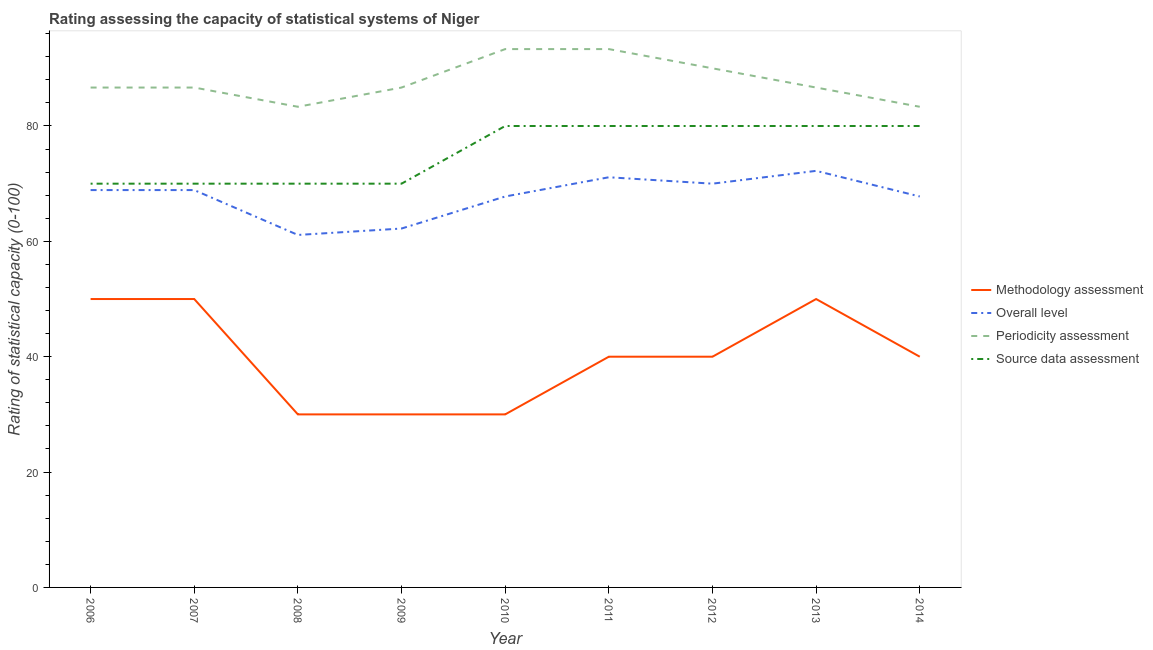Does the line corresponding to source data assessment rating intersect with the line corresponding to periodicity assessment rating?
Offer a terse response. No. Is the number of lines equal to the number of legend labels?
Make the answer very short. Yes. What is the methodology assessment rating in 2011?
Your response must be concise. 40. Across all years, what is the maximum methodology assessment rating?
Provide a succinct answer. 50. Across all years, what is the minimum source data assessment rating?
Your answer should be compact. 70. In which year was the periodicity assessment rating maximum?
Give a very brief answer. 2010. What is the total source data assessment rating in the graph?
Keep it short and to the point. 680. What is the difference between the periodicity assessment rating in 2010 and that in 2012?
Your answer should be very brief. 3.33. What is the difference between the periodicity assessment rating in 2010 and the methodology assessment rating in 2008?
Your response must be concise. 63.33. What is the average source data assessment rating per year?
Give a very brief answer. 75.56. In the year 2008, what is the difference between the periodicity assessment rating and overall level rating?
Provide a succinct answer. 22.22. In how many years, is the methodology assessment rating greater than 44?
Give a very brief answer. 3. What is the ratio of the periodicity assessment rating in 2006 to that in 2013?
Offer a terse response. 1. Is the methodology assessment rating in 2011 less than that in 2012?
Provide a short and direct response. No. Is the difference between the methodology assessment rating in 2007 and 2010 greater than the difference between the source data assessment rating in 2007 and 2010?
Keep it short and to the point. Yes. What is the difference between the highest and the lowest overall level rating?
Offer a terse response. 11.11. In how many years, is the overall level rating greater than the average overall level rating taken over all years?
Give a very brief answer. 7. Is it the case that in every year, the sum of the methodology assessment rating and overall level rating is greater than the periodicity assessment rating?
Offer a very short reply. Yes. Is the methodology assessment rating strictly greater than the overall level rating over the years?
Your answer should be compact. No. How many lines are there?
Ensure brevity in your answer.  4. How many years are there in the graph?
Keep it short and to the point. 9. What is the difference between two consecutive major ticks on the Y-axis?
Provide a short and direct response. 20. Does the graph contain grids?
Your response must be concise. No. Where does the legend appear in the graph?
Make the answer very short. Center right. How many legend labels are there?
Make the answer very short. 4. How are the legend labels stacked?
Your response must be concise. Vertical. What is the title of the graph?
Your answer should be very brief. Rating assessing the capacity of statistical systems of Niger. What is the label or title of the Y-axis?
Your answer should be compact. Rating of statistical capacity (0-100). What is the Rating of statistical capacity (0-100) of Methodology assessment in 2006?
Keep it short and to the point. 50. What is the Rating of statistical capacity (0-100) of Overall level in 2006?
Offer a very short reply. 68.89. What is the Rating of statistical capacity (0-100) of Periodicity assessment in 2006?
Give a very brief answer. 86.67. What is the Rating of statistical capacity (0-100) in Methodology assessment in 2007?
Keep it short and to the point. 50. What is the Rating of statistical capacity (0-100) of Overall level in 2007?
Your answer should be compact. 68.89. What is the Rating of statistical capacity (0-100) in Periodicity assessment in 2007?
Keep it short and to the point. 86.67. What is the Rating of statistical capacity (0-100) in Methodology assessment in 2008?
Provide a succinct answer. 30. What is the Rating of statistical capacity (0-100) in Overall level in 2008?
Make the answer very short. 61.11. What is the Rating of statistical capacity (0-100) of Periodicity assessment in 2008?
Offer a very short reply. 83.33. What is the Rating of statistical capacity (0-100) of Source data assessment in 2008?
Provide a short and direct response. 70. What is the Rating of statistical capacity (0-100) in Overall level in 2009?
Keep it short and to the point. 62.22. What is the Rating of statistical capacity (0-100) of Periodicity assessment in 2009?
Make the answer very short. 86.67. What is the Rating of statistical capacity (0-100) of Methodology assessment in 2010?
Keep it short and to the point. 30. What is the Rating of statistical capacity (0-100) in Overall level in 2010?
Make the answer very short. 67.78. What is the Rating of statistical capacity (0-100) in Periodicity assessment in 2010?
Offer a terse response. 93.33. What is the Rating of statistical capacity (0-100) of Source data assessment in 2010?
Offer a terse response. 80. What is the Rating of statistical capacity (0-100) of Overall level in 2011?
Make the answer very short. 71.11. What is the Rating of statistical capacity (0-100) of Periodicity assessment in 2011?
Your response must be concise. 93.33. What is the Rating of statistical capacity (0-100) in Source data assessment in 2011?
Provide a short and direct response. 80. What is the Rating of statistical capacity (0-100) of Overall level in 2012?
Offer a very short reply. 70. What is the Rating of statistical capacity (0-100) of Methodology assessment in 2013?
Keep it short and to the point. 50. What is the Rating of statistical capacity (0-100) in Overall level in 2013?
Offer a very short reply. 72.22. What is the Rating of statistical capacity (0-100) of Periodicity assessment in 2013?
Your answer should be compact. 86.67. What is the Rating of statistical capacity (0-100) in Methodology assessment in 2014?
Your answer should be compact. 40. What is the Rating of statistical capacity (0-100) in Overall level in 2014?
Your answer should be compact. 67.78. What is the Rating of statistical capacity (0-100) of Periodicity assessment in 2014?
Offer a very short reply. 83.33. Across all years, what is the maximum Rating of statistical capacity (0-100) of Overall level?
Ensure brevity in your answer.  72.22. Across all years, what is the maximum Rating of statistical capacity (0-100) in Periodicity assessment?
Offer a terse response. 93.33. Across all years, what is the minimum Rating of statistical capacity (0-100) in Overall level?
Provide a succinct answer. 61.11. Across all years, what is the minimum Rating of statistical capacity (0-100) in Periodicity assessment?
Your response must be concise. 83.33. What is the total Rating of statistical capacity (0-100) in Methodology assessment in the graph?
Give a very brief answer. 360. What is the total Rating of statistical capacity (0-100) of Overall level in the graph?
Keep it short and to the point. 610. What is the total Rating of statistical capacity (0-100) of Periodicity assessment in the graph?
Your answer should be compact. 790. What is the total Rating of statistical capacity (0-100) in Source data assessment in the graph?
Your answer should be compact. 680. What is the difference between the Rating of statistical capacity (0-100) in Periodicity assessment in 2006 and that in 2007?
Offer a terse response. 0. What is the difference between the Rating of statistical capacity (0-100) of Methodology assessment in 2006 and that in 2008?
Make the answer very short. 20. What is the difference between the Rating of statistical capacity (0-100) of Overall level in 2006 and that in 2008?
Provide a succinct answer. 7.78. What is the difference between the Rating of statistical capacity (0-100) of Methodology assessment in 2006 and that in 2009?
Your answer should be very brief. 20. What is the difference between the Rating of statistical capacity (0-100) of Overall level in 2006 and that in 2009?
Your answer should be very brief. 6.67. What is the difference between the Rating of statistical capacity (0-100) in Periodicity assessment in 2006 and that in 2009?
Give a very brief answer. 0. What is the difference between the Rating of statistical capacity (0-100) in Periodicity assessment in 2006 and that in 2010?
Make the answer very short. -6.67. What is the difference between the Rating of statistical capacity (0-100) in Source data assessment in 2006 and that in 2010?
Give a very brief answer. -10. What is the difference between the Rating of statistical capacity (0-100) of Methodology assessment in 2006 and that in 2011?
Give a very brief answer. 10. What is the difference between the Rating of statistical capacity (0-100) in Overall level in 2006 and that in 2011?
Keep it short and to the point. -2.22. What is the difference between the Rating of statistical capacity (0-100) of Periodicity assessment in 2006 and that in 2011?
Keep it short and to the point. -6.67. What is the difference between the Rating of statistical capacity (0-100) of Overall level in 2006 and that in 2012?
Offer a very short reply. -1.11. What is the difference between the Rating of statistical capacity (0-100) in Methodology assessment in 2006 and that in 2013?
Your answer should be very brief. 0. What is the difference between the Rating of statistical capacity (0-100) in Overall level in 2006 and that in 2013?
Your answer should be very brief. -3.33. What is the difference between the Rating of statistical capacity (0-100) of Periodicity assessment in 2006 and that in 2013?
Keep it short and to the point. 0. What is the difference between the Rating of statistical capacity (0-100) in Source data assessment in 2006 and that in 2013?
Your response must be concise. -10. What is the difference between the Rating of statistical capacity (0-100) in Methodology assessment in 2006 and that in 2014?
Make the answer very short. 10. What is the difference between the Rating of statistical capacity (0-100) of Overall level in 2006 and that in 2014?
Your answer should be very brief. 1.11. What is the difference between the Rating of statistical capacity (0-100) in Periodicity assessment in 2006 and that in 2014?
Provide a short and direct response. 3.33. What is the difference between the Rating of statistical capacity (0-100) of Source data assessment in 2006 and that in 2014?
Offer a terse response. -10. What is the difference between the Rating of statistical capacity (0-100) in Overall level in 2007 and that in 2008?
Make the answer very short. 7.78. What is the difference between the Rating of statistical capacity (0-100) in Periodicity assessment in 2007 and that in 2008?
Offer a terse response. 3.33. What is the difference between the Rating of statistical capacity (0-100) of Periodicity assessment in 2007 and that in 2009?
Give a very brief answer. 0. What is the difference between the Rating of statistical capacity (0-100) of Source data assessment in 2007 and that in 2009?
Your answer should be compact. 0. What is the difference between the Rating of statistical capacity (0-100) in Methodology assessment in 2007 and that in 2010?
Provide a succinct answer. 20. What is the difference between the Rating of statistical capacity (0-100) in Overall level in 2007 and that in 2010?
Offer a terse response. 1.11. What is the difference between the Rating of statistical capacity (0-100) of Periodicity assessment in 2007 and that in 2010?
Provide a short and direct response. -6.67. What is the difference between the Rating of statistical capacity (0-100) in Overall level in 2007 and that in 2011?
Provide a succinct answer. -2.22. What is the difference between the Rating of statistical capacity (0-100) in Periodicity assessment in 2007 and that in 2011?
Make the answer very short. -6.67. What is the difference between the Rating of statistical capacity (0-100) in Source data assessment in 2007 and that in 2011?
Offer a very short reply. -10. What is the difference between the Rating of statistical capacity (0-100) in Overall level in 2007 and that in 2012?
Make the answer very short. -1.11. What is the difference between the Rating of statistical capacity (0-100) in Source data assessment in 2007 and that in 2012?
Your answer should be compact. -10. What is the difference between the Rating of statistical capacity (0-100) in Overall level in 2007 and that in 2013?
Make the answer very short. -3.33. What is the difference between the Rating of statistical capacity (0-100) in Periodicity assessment in 2007 and that in 2013?
Your answer should be compact. 0. What is the difference between the Rating of statistical capacity (0-100) of Source data assessment in 2007 and that in 2013?
Offer a terse response. -10. What is the difference between the Rating of statistical capacity (0-100) of Methodology assessment in 2007 and that in 2014?
Your response must be concise. 10. What is the difference between the Rating of statistical capacity (0-100) in Overall level in 2007 and that in 2014?
Provide a succinct answer. 1.11. What is the difference between the Rating of statistical capacity (0-100) of Periodicity assessment in 2007 and that in 2014?
Make the answer very short. 3.33. What is the difference between the Rating of statistical capacity (0-100) of Source data assessment in 2007 and that in 2014?
Give a very brief answer. -10. What is the difference between the Rating of statistical capacity (0-100) of Methodology assessment in 2008 and that in 2009?
Your answer should be very brief. 0. What is the difference between the Rating of statistical capacity (0-100) of Overall level in 2008 and that in 2009?
Ensure brevity in your answer.  -1.11. What is the difference between the Rating of statistical capacity (0-100) of Source data assessment in 2008 and that in 2009?
Give a very brief answer. 0. What is the difference between the Rating of statistical capacity (0-100) in Overall level in 2008 and that in 2010?
Give a very brief answer. -6.67. What is the difference between the Rating of statistical capacity (0-100) of Source data assessment in 2008 and that in 2010?
Provide a succinct answer. -10. What is the difference between the Rating of statistical capacity (0-100) in Overall level in 2008 and that in 2011?
Your response must be concise. -10. What is the difference between the Rating of statistical capacity (0-100) of Source data assessment in 2008 and that in 2011?
Provide a succinct answer. -10. What is the difference between the Rating of statistical capacity (0-100) in Overall level in 2008 and that in 2012?
Your response must be concise. -8.89. What is the difference between the Rating of statistical capacity (0-100) in Periodicity assessment in 2008 and that in 2012?
Your answer should be very brief. -6.67. What is the difference between the Rating of statistical capacity (0-100) of Source data assessment in 2008 and that in 2012?
Offer a terse response. -10. What is the difference between the Rating of statistical capacity (0-100) in Methodology assessment in 2008 and that in 2013?
Keep it short and to the point. -20. What is the difference between the Rating of statistical capacity (0-100) of Overall level in 2008 and that in 2013?
Your response must be concise. -11.11. What is the difference between the Rating of statistical capacity (0-100) in Periodicity assessment in 2008 and that in 2013?
Give a very brief answer. -3.33. What is the difference between the Rating of statistical capacity (0-100) in Source data assessment in 2008 and that in 2013?
Your response must be concise. -10. What is the difference between the Rating of statistical capacity (0-100) in Overall level in 2008 and that in 2014?
Provide a succinct answer. -6.67. What is the difference between the Rating of statistical capacity (0-100) in Source data assessment in 2008 and that in 2014?
Keep it short and to the point. -10. What is the difference between the Rating of statistical capacity (0-100) of Overall level in 2009 and that in 2010?
Your response must be concise. -5.56. What is the difference between the Rating of statistical capacity (0-100) of Periodicity assessment in 2009 and that in 2010?
Ensure brevity in your answer.  -6.67. What is the difference between the Rating of statistical capacity (0-100) in Methodology assessment in 2009 and that in 2011?
Make the answer very short. -10. What is the difference between the Rating of statistical capacity (0-100) in Overall level in 2009 and that in 2011?
Keep it short and to the point. -8.89. What is the difference between the Rating of statistical capacity (0-100) of Periodicity assessment in 2009 and that in 2011?
Your response must be concise. -6.67. What is the difference between the Rating of statistical capacity (0-100) in Source data assessment in 2009 and that in 2011?
Keep it short and to the point. -10. What is the difference between the Rating of statistical capacity (0-100) in Overall level in 2009 and that in 2012?
Your answer should be very brief. -7.78. What is the difference between the Rating of statistical capacity (0-100) in Source data assessment in 2009 and that in 2012?
Keep it short and to the point. -10. What is the difference between the Rating of statistical capacity (0-100) of Periodicity assessment in 2009 and that in 2013?
Give a very brief answer. 0. What is the difference between the Rating of statistical capacity (0-100) in Source data assessment in 2009 and that in 2013?
Your answer should be compact. -10. What is the difference between the Rating of statistical capacity (0-100) in Methodology assessment in 2009 and that in 2014?
Provide a succinct answer. -10. What is the difference between the Rating of statistical capacity (0-100) in Overall level in 2009 and that in 2014?
Give a very brief answer. -5.56. What is the difference between the Rating of statistical capacity (0-100) of Source data assessment in 2009 and that in 2014?
Your answer should be very brief. -10. What is the difference between the Rating of statistical capacity (0-100) of Periodicity assessment in 2010 and that in 2011?
Your answer should be compact. 0. What is the difference between the Rating of statistical capacity (0-100) of Overall level in 2010 and that in 2012?
Keep it short and to the point. -2.22. What is the difference between the Rating of statistical capacity (0-100) in Periodicity assessment in 2010 and that in 2012?
Provide a short and direct response. 3.33. What is the difference between the Rating of statistical capacity (0-100) in Methodology assessment in 2010 and that in 2013?
Provide a succinct answer. -20. What is the difference between the Rating of statistical capacity (0-100) of Overall level in 2010 and that in 2013?
Provide a short and direct response. -4.44. What is the difference between the Rating of statistical capacity (0-100) of Overall level in 2010 and that in 2014?
Give a very brief answer. 0. What is the difference between the Rating of statistical capacity (0-100) of Source data assessment in 2011 and that in 2012?
Keep it short and to the point. 0. What is the difference between the Rating of statistical capacity (0-100) in Methodology assessment in 2011 and that in 2013?
Offer a terse response. -10. What is the difference between the Rating of statistical capacity (0-100) in Overall level in 2011 and that in 2013?
Your response must be concise. -1.11. What is the difference between the Rating of statistical capacity (0-100) in Periodicity assessment in 2011 and that in 2014?
Your answer should be compact. 10. What is the difference between the Rating of statistical capacity (0-100) in Source data assessment in 2011 and that in 2014?
Give a very brief answer. 0. What is the difference between the Rating of statistical capacity (0-100) of Methodology assessment in 2012 and that in 2013?
Ensure brevity in your answer.  -10. What is the difference between the Rating of statistical capacity (0-100) of Overall level in 2012 and that in 2013?
Provide a succinct answer. -2.22. What is the difference between the Rating of statistical capacity (0-100) in Methodology assessment in 2012 and that in 2014?
Your answer should be very brief. 0. What is the difference between the Rating of statistical capacity (0-100) of Overall level in 2012 and that in 2014?
Give a very brief answer. 2.22. What is the difference between the Rating of statistical capacity (0-100) of Periodicity assessment in 2012 and that in 2014?
Offer a very short reply. 6.67. What is the difference between the Rating of statistical capacity (0-100) of Methodology assessment in 2013 and that in 2014?
Give a very brief answer. 10. What is the difference between the Rating of statistical capacity (0-100) of Overall level in 2013 and that in 2014?
Keep it short and to the point. 4.44. What is the difference between the Rating of statistical capacity (0-100) of Periodicity assessment in 2013 and that in 2014?
Provide a short and direct response. 3.33. What is the difference between the Rating of statistical capacity (0-100) of Source data assessment in 2013 and that in 2014?
Your answer should be compact. 0. What is the difference between the Rating of statistical capacity (0-100) in Methodology assessment in 2006 and the Rating of statistical capacity (0-100) in Overall level in 2007?
Give a very brief answer. -18.89. What is the difference between the Rating of statistical capacity (0-100) in Methodology assessment in 2006 and the Rating of statistical capacity (0-100) in Periodicity assessment in 2007?
Your answer should be very brief. -36.67. What is the difference between the Rating of statistical capacity (0-100) in Overall level in 2006 and the Rating of statistical capacity (0-100) in Periodicity assessment in 2007?
Give a very brief answer. -17.78. What is the difference between the Rating of statistical capacity (0-100) in Overall level in 2006 and the Rating of statistical capacity (0-100) in Source data assessment in 2007?
Make the answer very short. -1.11. What is the difference between the Rating of statistical capacity (0-100) in Periodicity assessment in 2006 and the Rating of statistical capacity (0-100) in Source data assessment in 2007?
Provide a succinct answer. 16.67. What is the difference between the Rating of statistical capacity (0-100) in Methodology assessment in 2006 and the Rating of statistical capacity (0-100) in Overall level in 2008?
Offer a very short reply. -11.11. What is the difference between the Rating of statistical capacity (0-100) of Methodology assessment in 2006 and the Rating of statistical capacity (0-100) of Periodicity assessment in 2008?
Offer a very short reply. -33.33. What is the difference between the Rating of statistical capacity (0-100) of Methodology assessment in 2006 and the Rating of statistical capacity (0-100) of Source data assessment in 2008?
Provide a succinct answer. -20. What is the difference between the Rating of statistical capacity (0-100) of Overall level in 2006 and the Rating of statistical capacity (0-100) of Periodicity assessment in 2008?
Offer a terse response. -14.44. What is the difference between the Rating of statistical capacity (0-100) in Overall level in 2006 and the Rating of statistical capacity (0-100) in Source data assessment in 2008?
Offer a terse response. -1.11. What is the difference between the Rating of statistical capacity (0-100) of Periodicity assessment in 2006 and the Rating of statistical capacity (0-100) of Source data assessment in 2008?
Offer a terse response. 16.67. What is the difference between the Rating of statistical capacity (0-100) of Methodology assessment in 2006 and the Rating of statistical capacity (0-100) of Overall level in 2009?
Your answer should be very brief. -12.22. What is the difference between the Rating of statistical capacity (0-100) of Methodology assessment in 2006 and the Rating of statistical capacity (0-100) of Periodicity assessment in 2009?
Give a very brief answer. -36.67. What is the difference between the Rating of statistical capacity (0-100) of Overall level in 2006 and the Rating of statistical capacity (0-100) of Periodicity assessment in 2009?
Ensure brevity in your answer.  -17.78. What is the difference between the Rating of statistical capacity (0-100) in Overall level in 2006 and the Rating of statistical capacity (0-100) in Source data assessment in 2009?
Keep it short and to the point. -1.11. What is the difference between the Rating of statistical capacity (0-100) in Periodicity assessment in 2006 and the Rating of statistical capacity (0-100) in Source data assessment in 2009?
Keep it short and to the point. 16.67. What is the difference between the Rating of statistical capacity (0-100) of Methodology assessment in 2006 and the Rating of statistical capacity (0-100) of Overall level in 2010?
Provide a succinct answer. -17.78. What is the difference between the Rating of statistical capacity (0-100) of Methodology assessment in 2006 and the Rating of statistical capacity (0-100) of Periodicity assessment in 2010?
Offer a very short reply. -43.33. What is the difference between the Rating of statistical capacity (0-100) in Methodology assessment in 2006 and the Rating of statistical capacity (0-100) in Source data assessment in 2010?
Make the answer very short. -30. What is the difference between the Rating of statistical capacity (0-100) in Overall level in 2006 and the Rating of statistical capacity (0-100) in Periodicity assessment in 2010?
Your answer should be compact. -24.44. What is the difference between the Rating of statistical capacity (0-100) of Overall level in 2006 and the Rating of statistical capacity (0-100) of Source data assessment in 2010?
Your answer should be compact. -11.11. What is the difference between the Rating of statistical capacity (0-100) of Methodology assessment in 2006 and the Rating of statistical capacity (0-100) of Overall level in 2011?
Provide a short and direct response. -21.11. What is the difference between the Rating of statistical capacity (0-100) of Methodology assessment in 2006 and the Rating of statistical capacity (0-100) of Periodicity assessment in 2011?
Keep it short and to the point. -43.33. What is the difference between the Rating of statistical capacity (0-100) in Overall level in 2006 and the Rating of statistical capacity (0-100) in Periodicity assessment in 2011?
Keep it short and to the point. -24.44. What is the difference between the Rating of statistical capacity (0-100) in Overall level in 2006 and the Rating of statistical capacity (0-100) in Source data assessment in 2011?
Your response must be concise. -11.11. What is the difference between the Rating of statistical capacity (0-100) in Periodicity assessment in 2006 and the Rating of statistical capacity (0-100) in Source data assessment in 2011?
Your response must be concise. 6.67. What is the difference between the Rating of statistical capacity (0-100) in Methodology assessment in 2006 and the Rating of statistical capacity (0-100) in Overall level in 2012?
Your answer should be compact. -20. What is the difference between the Rating of statistical capacity (0-100) in Methodology assessment in 2006 and the Rating of statistical capacity (0-100) in Source data assessment in 2012?
Make the answer very short. -30. What is the difference between the Rating of statistical capacity (0-100) in Overall level in 2006 and the Rating of statistical capacity (0-100) in Periodicity assessment in 2012?
Keep it short and to the point. -21.11. What is the difference between the Rating of statistical capacity (0-100) of Overall level in 2006 and the Rating of statistical capacity (0-100) of Source data assessment in 2012?
Offer a very short reply. -11.11. What is the difference between the Rating of statistical capacity (0-100) of Periodicity assessment in 2006 and the Rating of statistical capacity (0-100) of Source data assessment in 2012?
Provide a succinct answer. 6.67. What is the difference between the Rating of statistical capacity (0-100) of Methodology assessment in 2006 and the Rating of statistical capacity (0-100) of Overall level in 2013?
Your answer should be compact. -22.22. What is the difference between the Rating of statistical capacity (0-100) of Methodology assessment in 2006 and the Rating of statistical capacity (0-100) of Periodicity assessment in 2013?
Keep it short and to the point. -36.67. What is the difference between the Rating of statistical capacity (0-100) of Overall level in 2006 and the Rating of statistical capacity (0-100) of Periodicity assessment in 2013?
Your response must be concise. -17.78. What is the difference between the Rating of statistical capacity (0-100) of Overall level in 2006 and the Rating of statistical capacity (0-100) of Source data assessment in 2013?
Provide a short and direct response. -11.11. What is the difference between the Rating of statistical capacity (0-100) of Periodicity assessment in 2006 and the Rating of statistical capacity (0-100) of Source data assessment in 2013?
Ensure brevity in your answer.  6.67. What is the difference between the Rating of statistical capacity (0-100) of Methodology assessment in 2006 and the Rating of statistical capacity (0-100) of Overall level in 2014?
Your answer should be compact. -17.78. What is the difference between the Rating of statistical capacity (0-100) of Methodology assessment in 2006 and the Rating of statistical capacity (0-100) of Periodicity assessment in 2014?
Provide a succinct answer. -33.33. What is the difference between the Rating of statistical capacity (0-100) of Overall level in 2006 and the Rating of statistical capacity (0-100) of Periodicity assessment in 2014?
Your response must be concise. -14.44. What is the difference between the Rating of statistical capacity (0-100) of Overall level in 2006 and the Rating of statistical capacity (0-100) of Source data assessment in 2014?
Your answer should be very brief. -11.11. What is the difference between the Rating of statistical capacity (0-100) in Methodology assessment in 2007 and the Rating of statistical capacity (0-100) in Overall level in 2008?
Offer a very short reply. -11.11. What is the difference between the Rating of statistical capacity (0-100) in Methodology assessment in 2007 and the Rating of statistical capacity (0-100) in Periodicity assessment in 2008?
Provide a succinct answer. -33.33. What is the difference between the Rating of statistical capacity (0-100) of Overall level in 2007 and the Rating of statistical capacity (0-100) of Periodicity assessment in 2008?
Offer a very short reply. -14.44. What is the difference between the Rating of statistical capacity (0-100) of Overall level in 2007 and the Rating of statistical capacity (0-100) of Source data assessment in 2008?
Offer a very short reply. -1.11. What is the difference between the Rating of statistical capacity (0-100) in Periodicity assessment in 2007 and the Rating of statistical capacity (0-100) in Source data assessment in 2008?
Make the answer very short. 16.67. What is the difference between the Rating of statistical capacity (0-100) in Methodology assessment in 2007 and the Rating of statistical capacity (0-100) in Overall level in 2009?
Offer a terse response. -12.22. What is the difference between the Rating of statistical capacity (0-100) in Methodology assessment in 2007 and the Rating of statistical capacity (0-100) in Periodicity assessment in 2009?
Make the answer very short. -36.67. What is the difference between the Rating of statistical capacity (0-100) in Overall level in 2007 and the Rating of statistical capacity (0-100) in Periodicity assessment in 2009?
Provide a short and direct response. -17.78. What is the difference between the Rating of statistical capacity (0-100) of Overall level in 2007 and the Rating of statistical capacity (0-100) of Source data assessment in 2009?
Offer a terse response. -1.11. What is the difference between the Rating of statistical capacity (0-100) of Periodicity assessment in 2007 and the Rating of statistical capacity (0-100) of Source data assessment in 2009?
Your answer should be compact. 16.67. What is the difference between the Rating of statistical capacity (0-100) of Methodology assessment in 2007 and the Rating of statistical capacity (0-100) of Overall level in 2010?
Your response must be concise. -17.78. What is the difference between the Rating of statistical capacity (0-100) in Methodology assessment in 2007 and the Rating of statistical capacity (0-100) in Periodicity assessment in 2010?
Provide a succinct answer. -43.33. What is the difference between the Rating of statistical capacity (0-100) in Overall level in 2007 and the Rating of statistical capacity (0-100) in Periodicity assessment in 2010?
Keep it short and to the point. -24.44. What is the difference between the Rating of statistical capacity (0-100) of Overall level in 2007 and the Rating of statistical capacity (0-100) of Source data assessment in 2010?
Your answer should be compact. -11.11. What is the difference between the Rating of statistical capacity (0-100) in Periodicity assessment in 2007 and the Rating of statistical capacity (0-100) in Source data assessment in 2010?
Ensure brevity in your answer.  6.67. What is the difference between the Rating of statistical capacity (0-100) in Methodology assessment in 2007 and the Rating of statistical capacity (0-100) in Overall level in 2011?
Provide a short and direct response. -21.11. What is the difference between the Rating of statistical capacity (0-100) in Methodology assessment in 2007 and the Rating of statistical capacity (0-100) in Periodicity assessment in 2011?
Your answer should be very brief. -43.33. What is the difference between the Rating of statistical capacity (0-100) of Overall level in 2007 and the Rating of statistical capacity (0-100) of Periodicity assessment in 2011?
Your answer should be compact. -24.44. What is the difference between the Rating of statistical capacity (0-100) of Overall level in 2007 and the Rating of statistical capacity (0-100) of Source data assessment in 2011?
Offer a very short reply. -11.11. What is the difference between the Rating of statistical capacity (0-100) in Methodology assessment in 2007 and the Rating of statistical capacity (0-100) in Periodicity assessment in 2012?
Your answer should be very brief. -40. What is the difference between the Rating of statistical capacity (0-100) of Methodology assessment in 2007 and the Rating of statistical capacity (0-100) of Source data assessment in 2012?
Ensure brevity in your answer.  -30. What is the difference between the Rating of statistical capacity (0-100) in Overall level in 2007 and the Rating of statistical capacity (0-100) in Periodicity assessment in 2012?
Your response must be concise. -21.11. What is the difference between the Rating of statistical capacity (0-100) of Overall level in 2007 and the Rating of statistical capacity (0-100) of Source data assessment in 2012?
Your response must be concise. -11.11. What is the difference between the Rating of statistical capacity (0-100) in Periodicity assessment in 2007 and the Rating of statistical capacity (0-100) in Source data assessment in 2012?
Offer a terse response. 6.67. What is the difference between the Rating of statistical capacity (0-100) in Methodology assessment in 2007 and the Rating of statistical capacity (0-100) in Overall level in 2013?
Give a very brief answer. -22.22. What is the difference between the Rating of statistical capacity (0-100) in Methodology assessment in 2007 and the Rating of statistical capacity (0-100) in Periodicity assessment in 2013?
Offer a terse response. -36.67. What is the difference between the Rating of statistical capacity (0-100) of Overall level in 2007 and the Rating of statistical capacity (0-100) of Periodicity assessment in 2013?
Your response must be concise. -17.78. What is the difference between the Rating of statistical capacity (0-100) of Overall level in 2007 and the Rating of statistical capacity (0-100) of Source data assessment in 2013?
Give a very brief answer. -11.11. What is the difference between the Rating of statistical capacity (0-100) in Methodology assessment in 2007 and the Rating of statistical capacity (0-100) in Overall level in 2014?
Your answer should be very brief. -17.78. What is the difference between the Rating of statistical capacity (0-100) of Methodology assessment in 2007 and the Rating of statistical capacity (0-100) of Periodicity assessment in 2014?
Offer a terse response. -33.33. What is the difference between the Rating of statistical capacity (0-100) in Methodology assessment in 2007 and the Rating of statistical capacity (0-100) in Source data assessment in 2014?
Provide a succinct answer. -30. What is the difference between the Rating of statistical capacity (0-100) in Overall level in 2007 and the Rating of statistical capacity (0-100) in Periodicity assessment in 2014?
Keep it short and to the point. -14.44. What is the difference between the Rating of statistical capacity (0-100) in Overall level in 2007 and the Rating of statistical capacity (0-100) in Source data assessment in 2014?
Your answer should be compact. -11.11. What is the difference between the Rating of statistical capacity (0-100) of Periodicity assessment in 2007 and the Rating of statistical capacity (0-100) of Source data assessment in 2014?
Offer a terse response. 6.67. What is the difference between the Rating of statistical capacity (0-100) in Methodology assessment in 2008 and the Rating of statistical capacity (0-100) in Overall level in 2009?
Make the answer very short. -32.22. What is the difference between the Rating of statistical capacity (0-100) of Methodology assessment in 2008 and the Rating of statistical capacity (0-100) of Periodicity assessment in 2009?
Your response must be concise. -56.67. What is the difference between the Rating of statistical capacity (0-100) of Methodology assessment in 2008 and the Rating of statistical capacity (0-100) of Source data assessment in 2009?
Offer a very short reply. -40. What is the difference between the Rating of statistical capacity (0-100) in Overall level in 2008 and the Rating of statistical capacity (0-100) in Periodicity assessment in 2009?
Offer a terse response. -25.56. What is the difference between the Rating of statistical capacity (0-100) of Overall level in 2008 and the Rating of statistical capacity (0-100) of Source data assessment in 2009?
Give a very brief answer. -8.89. What is the difference between the Rating of statistical capacity (0-100) in Periodicity assessment in 2008 and the Rating of statistical capacity (0-100) in Source data assessment in 2009?
Make the answer very short. 13.33. What is the difference between the Rating of statistical capacity (0-100) in Methodology assessment in 2008 and the Rating of statistical capacity (0-100) in Overall level in 2010?
Provide a succinct answer. -37.78. What is the difference between the Rating of statistical capacity (0-100) in Methodology assessment in 2008 and the Rating of statistical capacity (0-100) in Periodicity assessment in 2010?
Keep it short and to the point. -63.33. What is the difference between the Rating of statistical capacity (0-100) in Overall level in 2008 and the Rating of statistical capacity (0-100) in Periodicity assessment in 2010?
Your answer should be very brief. -32.22. What is the difference between the Rating of statistical capacity (0-100) in Overall level in 2008 and the Rating of statistical capacity (0-100) in Source data assessment in 2010?
Provide a short and direct response. -18.89. What is the difference between the Rating of statistical capacity (0-100) of Periodicity assessment in 2008 and the Rating of statistical capacity (0-100) of Source data assessment in 2010?
Provide a short and direct response. 3.33. What is the difference between the Rating of statistical capacity (0-100) of Methodology assessment in 2008 and the Rating of statistical capacity (0-100) of Overall level in 2011?
Your answer should be very brief. -41.11. What is the difference between the Rating of statistical capacity (0-100) in Methodology assessment in 2008 and the Rating of statistical capacity (0-100) in Periodicity assessment in 2011?
Make the answer very short. -63.33. What is the difference between the Rating of statistical capacity (0-100) of Overall level in 2008 and the Rating of statistical capacity (0-100) of Periodicity assessment in 2011?
Your response must be concise. -32.22. What is the difference between the Rating of statistical capacity (0-100) in Overall level in 2008 and the Rating of statistical capacity (0-100) in Source data assessment in 2011?
Offer a very short reply. -18.89. What is the difference between the Rating of statistical capacity (0-100) in Methodology assessment in 2008 and the Rating of statistical capacity (0-100) in Overall level in 2012?
Ensure brevity in your answer.  -40. What is the difference between the Rating of statistical capacity (0-100) in Methodology assessment in 2008 and the Rating of statistical capacity (0-100) in Periodicity assessment in 2012?
Keep it short and to the point. -60. What is the difference between the Rating of statistical capacity (0-100) in Methodology assessment in 2008 and the Rating of statistical capacity (0-100) in Source data assessment in 2012?
Provide a short and direct response. -50. What is the difference between the Rating of statistical capacity (0-100) in Overall level in 2008 and the Rating of statistical capacity (0-100) in Periodicity assessment in 2012?
Your answer should be very brief. -28.89. What is the difference between the Rating of statistical capacity (0-100) of Overall level in 2008 and the Rating of statistical capacity (0-100) of Source data assessment in 2012?
Your answer should be compact. -18.89. What is the difference between the Rating of statistical capacity (0-100) in Methodology assessment in 2008 and the Rating of statistical capacity (0-100) in Overall level in 2013?
Your response must be concise. -42.22. What is the difference between the Rating of statistical capacity (0-100) of Methodology assessment in 2008 and the Rating of statistical capacity (0-100) of Periodicity assessment in 2013?
Your answer should be compact. -56.67. What is the difference between the Rating of statistical capacity (0-100) of Overall level in 2008 and the Rating of statistical capacity (0-100) of Periodicity assessment in 2013?
Ensure brevity in your answer.  -25.56. What is the difference between the Rating of statistical capacity (0-100) of Overall level in 2008 and the Rating of statistical capacity (0-100) of Source data assessment in 2013?
Offer a terse response. -18.89. What is the difference between the Rating of statistical capacity (0-100) in Methodology assessment in 2008 and the Rating of statistical capacity (0-100) in Overall level in 2014?
Offer a very short reply. -37.78. What is the difference between the Rating of statistical capacity (0-100) of Methodology assessment in 2008 and the Rating of statistical capacity (0-100) of Periodicity assessment in 2014?
Offer a terse response. -53.33. What is the difference between the Rating of statistical capacity (0-100) of Methodology assessment in 2008 and the Rating of statistical capacity (0-100) of Source data assessment in 2014?
Your answer should be very brief. -50. What is the difference between the Rating of statistical capacity (0-100) of Overall level in 2008 and the Rating of statistical capacity (0-100) of Periodicity assessment in 2014?
Your answer should be very brief. -22.22. What is the difference between the Rating of statistical capacity (0-100) of Overall level in 2008 and the Rating of statistical capacity (0-100) of Source data assessment in 2014?
Your answer should be compact. -18.89. What is the difference between the Rating of statistical capacity (0-100) in Periodicity assessment in 2008 and the Rating of statistical capacity (0-100) in Source data assessment in 2014?
Your answer should be compact. 3.33. What is the difference between the Rating of statistical capacity (0-100) in Methodology assessment in 2009 and the Rating of statistical capacity (0-100) in Overall level in 2010?
Offer a terse response. -37.78. What is the difference between the Rating of statistical capacity (0-100) in Methodology assessment in 2009 and the Rating of statistical capacity (0-100) in Periodicity assessment in 2010?
Provide a succinct answer. -63.33. What is the difference between the Rating of statistical capacity (0-100) in Overall level in 2009 and the Rating of statistical capacity (0-100) in Periodicity assessment in 2010?
Provide a short and direct response. -31.11. What is the difference between the Rating of statistical capacity (0-100) in Overall level in 2009 and the Rating of statistical capacity (0-100) in Source data assessment in 2010?
Your response must be concise. -17.78. What is the difference between the Rating of statistical capacity (0-100) in Periodicity assessment in 2009 and the Rating of statistical capacity (0-100) in Source data assessment in 2010?
Your answer should be compact. 6.67. What is the difference between the Rating of statistical capacity (0-100) in Methodology assessment in 2009 and the Rating of statistical capacity (0-100) in Overall level in 2011?
Ensure brevity in your answer.  -41.11. What is the difference between the Rating of statistical capacity (0-100) of Methodology assessment in 2009 and the Rating of statistical capacity (0-100) of Periodicity assessment in 2011?
Offer a very short reply. -63.33. What is the difference between the Rating of statistical capacity (0-100) of Methodology assessment in 2009 and the Rating of statistical capacity (0-100) of Source data assessment in 2011?
Ensure brevity in your answer.  -50. What is the difference between the Rating of statistical capacity (0-100) in Overall level in 2009 and the Rating of statistical capacity (0-100) in Periodicity assessment in 2011?
Provide a short and direct response. -31.11. What is the difference between the Rating of statistical capacity (0-100) of Overall level in 2009 and the Rating of statistical capacity (0-100) of Source data assessment in 2011?
Ensure brevity in your answer.  -17.78. What is the difference between the Rating of statistical capacity (0-100) in Methodology assessment in 2009 and the Rating of statistical capacity (0-100) in Overall level in 2012?
Provide a short and direct response. -40. What is the difference between the Rating of statistical capacity (0-100) of Methodology assessment in 2009 and the Rating of statistical capacity (0-100) of Periodicity assessment in 2012?
Your answer should be compact. -60. What is the difference between the Rating of statistical capacity (0-100) in Overall level in 2009 and the Rating of statistical capacity (0-100) in Periodicity assessment in 2012?
Provide a succinct answer. -27.78. What is the difference between the Rating of statistical capacity (0-100) in Overall level in 2009 and the Rating of statistical capacity (0-100) in Source data assessment in 2012?
Provide a succinct answer. -17.78. What is the difference between the Rating of statistical capacity (0-100) of Methodology assessment in 2009 and the Rating of statistical capacity (0-100) of Overall level in 2013?
Make the answer very short. -42.22. What is the difference between the Rating of statistical capacity (0-100) in Methodology assessment in 2009 and the Rating of statistical capacity (0-100) in Periodicity assessment in 2013?
Offer a very short reply. -56.67. What is the difference between the Rating of statistical capacity (0-100) in Overall level in 2009 and the Rating of statistical capacity (0-100) in Periodicity assessment in 2013?
Give a very brief answer. -24.44. What is the difference between the Rating of statistical capacity (0-100) in Overall level in 2009 and the Rating of statistical capacity (0-100) in Source data assessment in 2013?
Your answer should be compact. -17.78. What is the difference between the Rating of statistical capacity (0-100) in Periodicity assessment in 2009 and the Rating of statistical capacity (0-100) in Source data assessment in 2013?
Provide a short and direct response. 6.67. What is the difference between the Rating of statistical capacity (0-100) in Methodology assessment in 2009 and the Rating of statistical capacity (0-100) in Overall level in 2014?
Provide a short and direct response. -37.78. What is the difference between the Rating of statistical capacity (0-100) of Methodology assessment in 2009 and the Rating of statistical capacity (0-100) of Periodicity assessment in 2014?
Offer a terse response. -53.33. What is the difference between the Rating of statistical capacity (0-100) in Methodology assessment in 2009 and the Rating of statistical capacity (0-100) in Source data assessment in 2014?
Provide a short and direct response. -50. What is the difference between the Rating of statistical capacity (0-100) of Overall level in 2009 and the Rating of statistical capacity (0-100) of Periodicity assessment in 2014?
Provide a succinct answer. -21.11. What is the difference between the Rating of statistical capacity (0-100) of Overall level in 2009 and the Rating of statistical capacity (0-100) of Source data assessment in 2014?
Your answer should be very brief. -17.78. What is the difference between the Rating of statistical capacity (0-100) of Periodicity assessment in 2009 and the Rating of statistical capacity (0-100) of Source data assessment in 2014?
Your response must be concise. 6.67. What is the difference between the Rating of statistical capacity (0-100) of Methodology assessment in 2010 and the Rating of statistical capacity (0-100) of Overall level in 2011?
Offer a very short reply. -41.11. What is the difference between the Rating of statistical capacity (0-100) in Methodology assessment in 2010 and the Rating of statistical capacity (0-100) in Periodicity assessment in 2011?
Your response must be concise. -63.33. What is the difference between the Rating of statistical capacity (0-100) of Methodology assessment in 2010 and the Rating of statistical capacity (0-100) of Source data assessment in 2011?
Ensure brevity in your answer.  -50. What is the difference between the Rating of statistical capacity (0-100) of Overall level in 2010 and the Rating of statistical capacity (0-100) of Periodicity assessment in 2011?
Your answer should be compact. -25.56. What is the difference between the Rating of statistical capacity (0-100) of Overall level in 2010 and the Rating of statistical capacity (0-100) of Source data assessment in 2011?
Provide a short and direct response. -12.22. What is the difference between the Rating of statistical capacity (0-100) of Periodicity assessment in 2010 and the Rating of statistical capacity (0-100) of Source data assessment in 2011?
Give a very brief answer. 13.33. What is the difference between the Rating of statistical capacity (0-100) in Methodology assessment in 2010 and the Rating of statistical capacity (0-100) in Overall level in 2012?
Offer a very short reply. -40. What is the difference between the Rating of statistical capacity (0-100) of Methodology assessment in 2010 and the Rating of statistical capacity (0-100) of Periodicity assessment in 2012?
Your answer should be compact. -60. What is the difference between the Rating of statistical capacity (0-100) in Methodology assessment in 2010 and the Rating of statistical capacity (0-100) in Source data assessment in 2012?
Provide a succinct answer. -50. What is the difference between the Rating of statistical capacity (0-100) of Overall level in 2010 and the Rating of statistical capacity (0-100) of Periodicity assessment in 2012?
Offer a very short reply. -22.22. What is the difference between the Rating of statistical capacity (0-100) in Overall level in 2010 and the Rating of statistical capacity (0-100) in Source data assessment in 2012?
Your answer should be very brief. -12.22. What is the difference between the Rating of statistical capacity (0-100) in Periodicity assessment in 2010 and the Rating of statistical capacity (0-100) in Source data assessment in 2012?
Your answer should be compact. 13.33. What is the difference between the Rating of statistical capacity (0-100) of Methodology assessment in 2010 and the Rating of statistical capacity (0-100) of Overall level in 2013?
Offer a very short reply. -42.22. What is the difference between the Rating of statistical capacity (0-100) of Methodology assessment in 2010 and the Rating of statistical capacity (0-100) of Periodicity assessment in 2013?
Provide a succinct answer. -56.67. What is the difference between the Rating of statistical capacity (0-100) in Methodology assessment in 2010 and the Rating of statistical capacity (0-100) in Source data assessment in 2013?
Your response must be concise. -50. What is the difference between the Rating of statistical capacity (0-100) of Overall level in 2010 and the Rating of statistical capacity (0-100) of Periodicity assessment in 2013?
Offer a very short reply. -18.89. What is the difference between the Rating of statistical capacity (0-100) of Overall level in 2010 and the Rating of statistical capacity (0-100) of Source data assessment in 2013?
Offer a very short reply. -12.22. What is the difference between the Rating of statistical capacity (0-100) in Periodicity assessment in 2010 and the Rating of statistical capacity (0-100) in Source data assessment in 2013?
Offer a terse response. 13.33. What is the difference between the Rating of statistical capacity (0-100) of Methodology assessment in 2010 and the Rating of statistical capacity (0-100) of Overall level in 2014?
Offer a terse response. -37.78. What is the difference between the Rating of statistical capacity (0-100) in Methodology assessment in 2010 and the Rating of statistical capacity (0-100) in Periodicity assessment in 2014?
Your answer should be compact. -53.33. What is the difference between the Rating of statistical capacity (0-100) in Overall level in 2010 and the Rating of statistical capacity (0-100) in Periodicity assessment in 2014?
Your answer should be compact. -15.56. What is the difference between the Rating of statistical capacity (0-100) in Overall level in 2010 and the Rating of statistical capacity (0-100) in Source data assessment in 2014?
Your response must be concise. -12.22. What is the difference between the Rating of statistical capacity (0-100) of Periodicity assessment in 2010 and the Rating of statistical capacity (0-100) of Source data assessment in 2014?
Your answer should be very brief. 13.33. What is the difference between the Rating of statistical capacity (0-100) of Methodology assessment in 2011 and the Rating of statistical capacity (0-100) of Overall level in 2012?
Offer a very short reply. -30. What is the difference between the Rating of statistical capacity (0-100) in Methodology assessment in 2011 and the Rating of statistical capacity (0-100) in Periodicity assessment in 2012?
Make the answer very short. -50. What is the difference between the Rating of statistical capacity (0-100) of Methodology assessment in 2011 and the Rating of statistical capacity (0-100) of Source data assessment in 2012?
Your response must be concise. -40. What is the difference between the Rating of statistical capacity (0-100) in Overall level in 2011 and the Rating of statistical capacity (0-100) in Periodicity assessment in 2012?
Provide a short and direct response. -18.89. What is the difference between the Rating of statistical capacity (0-100) of Overall level in 2011 and the Rating of statistical capacity (0-100) of Source data assessment in 2012?
Keep it short and to the point. -8.89. What is the difference between the Rating of statistical capacity (0-100) of Periodicity assessment in 2011 and the Rating of statistical capacity (0-100) of Source data assessment in 2012?
Your response must be concise. 13.33. What is the difference between the Rating of statistical capacity (0-100) in Methodology assessment in 2011 and the Rating of statistical capacity (0-100) in Overall level in 2013?
Offer a terse response. -32.22. What is the difference between the Rating of statistical capacity (0-100) of Methodology assessment in 2011 and the Rating of statistical capacity (0-100) of Periodicity assessment in 2013?
Provide a short and direct response. -46.67. What is the difference between the Rating of statistical capacity (0-100) in Overall level in 2011 and the Rating of statistical capacity (0-100) in Periodicity assessment in 2013?
Offer a very short reply. -15.56. What is the difference between the Rating of statistical capacity (0-100) of Overall level in 2011 and the Rating of statistical capacity (0-100) of Source data assessment in 2013?
Keep it short and to the point. -8.89. What is the difference between the Rating of statistical capacity (0-100) in Periodicity assessment in 2011 and the Rating of statistical capacity (0-100) in Source data assessment in 2013?
Give a very brief answer. 13.33. What is the difference between the Rating of statistical capacity (0-100) in Methodology assessment in 2011 and the Rating of statistical capacity (0-100) in Overall level in 2014?
Your response must be concise. -27.78. What is the difference between the Rating of statistical capacity (0-100) in Methodology assessment in 2011 and the Rating of statistical capacity (0-100) in Periodicity assessment in 2014?
Your answer should be very brief. -43.33. What is the difference between the Rating of statistical capacity (0-100) in Methodology assessment in 2011 and the Rating of statistical capacity (0-100) in Source data assessment in 2014?
Make the answer very short. -40. What is the difference between the Rating of statistical capacity (0-100) in Overall level in 2011 and the Rating of statistical capacity (0-100) in Periodicity assessment in 2014?
Ensure brevity in your answer.  -12.22. What is the difference between the Rating of statistical capacity (0-100) of Overall level in 2011 and the Rating of statistical capacity (0-100) of Source data assessment in 2014?
Provide a short and direct response. -8.89. What is the difference between the Rating of statistical capacity (0-100) in Periodicity assessment in 2011 and the Rating of statistical capacity (0-100) in Source data assessment in 2014?
Offer a very short reply. 13.33. What is the difference between the Rating of statistical capacity (0-100) in Methodology assessment in 2012 and the Rating of statistical capacity (0-100) in Overall level in 2013?
Make the answer very short. -32.22. What is the difference between the Rating of statistical capacity (0-100) in Methodology assessment in 2012 and the Rating of statistical capacity (0-100) in Periodicity assessment in 2013?
Your response must be concise. -46.67. What is the difference between the Rating of statistical capacity (0-100) of Overall level in 2012 and the Rating of statistical capacity (0-100) of Periodicity assessment in 2013?
Your response must be concise. -16.67. What is the difference between the Rating of statistical capacity (0-100) of Periodicity assessment in 2012 and the Rating of statistical capacity (0-100) of Source data assessment in 2013?
Provide a succinct answer. 10. What is the difference between the Rating of statistical capacity (0-100) in Methodology assessment in 2012 and the Rating of statistical capacity (0-100) in Overall level in 2014?
Give a very brief answer. -27.78. What is the difference between the Rating of statistical capacity (0-100) in Methodology assessment in 2012 and the Rating of statistical capacity (0-100) in Periodicity assessment in 2014?
Your answer should be very brief. -43.33. What is the difference between the Rating of statistical capacity (0-100) of Methodology assessment in 2012 and the Rating of statistical capacity (0-100) of Source data assessment in 2014?
Make the answer very short. -40. What is the difference between the Rating of statistical capacity (0-100) in Overall level in 2012 and the Rating of statistical capacity (0-100) in Periodicity assessment in 2014?
Make the answer very short. -13.33. What is the difference between the Rating of statistical capacity (0-100) in Overall level in 2012 and the Rating of statistical capacity (0-100) in Source data assessment in 2014?
Your answer should be compact. -10. What is the difference between the Rating of statistical capacity (0-100) in Methodology assessment in 2013 and the Rating of statistical capacity (0-100) in Overall level in 2014?
Your answer should be compact. -17.78. What is the difference between the Rating of statistical capacity (0-100) of Methodology assessment in 2013 and the Rating of statistical capacity (0-100) of Periodicity assessment in 2014?
Offer a very short reply. -33.33. What is the difference between the Rating of statistical capacity (0-100) in Methodology assessment in 2013 and the Rating of statistical capacity (0-100) in Source data assessment in 2014?
Your answer should be very brief. -30. What is the difference between the Rating of statistical capacity (0-100) of Overall level in 2013 and the Rating of statistical capacity (0-100) of Periodicity assessment in 2014?
Ensure brevity in your answer.  -11.11. What is the difference between the Rating of statistical capacity (0-100) in Overall level in 2013 and the Rating of statistical capacity (0-100) in Source data assessment in 2014?
Your answer should be compact. -7.78. What is the average Rating of statistical capacity (0-100) in Methodology assessment per year?
Your answer should be very brief. 40. What is the average Rating of statistical capacity (0-100) in Overall level per year?
Keep it short and to the point. 67.78. What is the average Rating of statistical capacity (0-100) of Periodicity assessment per year?
Your answer should be very brief. 87.78. What is the average Rating of statistical capacity (0-100) in Source data assessment per year?
Your answer should be very brief. 75.56. In the year 2006, what is the difference between the Rating of statistical capacity (0-100) in Methodology assessment and Rating of statistical capacity (0-100) in Overall level?
Provide a short and direct response. -18.89. In the year 2006, what is the difference between the Rating of statistical capacity (0-100) in Methodology assessment and Rating of statistical capacity (0-100) in Periodicity assessment?
Keep it short and to the point. -36.67. In the year 2006, what is the difference between the Rating of statistical capacity (0-100) in Overall level and Rating of statistical capacity (0-100) in Periodicity assessment?
Your answer should be compact. -17.78. In the year 2006, what is the difference between the Rating of statistical capacity (0-100) in Overall level and Rating of statistical capacity (0-100) in Source data assessment?
Offer a very short reply. -1.11. In the year 2006, what is the difference between the Rating of statistical capacity (0-100) in Periodicity assessment and Rating of statistical capacity (0-100) in Source data assessment?
Your answer should be very brief. 16.67. In the year 2007, what is the difference between the Rating of statistical capacity (0-100) in Methodology assessment and Rating of statistical capacity (0-100) in Overall level?
Provide a succinct answer. -18.89. In the year 2007, what is the difference between the Rating of statistical capacity (0-100) of Methodology assessment and Rating of statistical capacity (0-100) of Periodicity assessment?
Offer a terse response. -36.67. In the year 2007, what is the difference between the Rating of statistical capacity (0-100) of Overall level and Rating of statistical capacity (0-100) of Periodicity assessment?
Keep it short and to the point. -17.78. In the year 2007, what is the difference between the Rating of statistical capacity (0-100) in Overall level and Rating of statistical capacity (0-100) in Source data assessment?
Give a very brief answer. -1.11. In the year 2007, what is the difference between the Rating of statistical capacity (0-100) in Periodicity assessment and Rating of statistical capacity (0-100) in Source data assessment?
Make the answer very short. 16.67. In the year 2008, what is the difference between the Rating of statistical capacity (0-100) in Methodology assessment and Rating of statistical capacity (0-100) in Overall level?
Ensure brevity in your answer.  -31.11. In the year 2008, what is the difference between the Rating of statistical capacity (0-100) in Methodology assessment and Rating of statistical capacity (0-100) in Periodicity assessment?
Offer a terse response. -53.33. In the year 2008, what is the difference between the Rating of statistical capacity (0-100) of Overall level and Rating of statistical capacity (0-100) of Periodicity assessment?
Your response must be concise. -22.22. In the year 2008, what is the difference between the Rating of statistical capacity (0-100) in Overall level and Rating of statistical capacity (0-100) in Source data assessment?
Your answer should be very brief. -8.89. In the year 2008, what is the difference between the Rating of statistical capacity (0-100) of Periodicity assessment and Rating of statistical capacity (0-100) of Source data assessment?
Make the answer very short. 13.33. In the year 2009, what is the difference between the Rating of statistical capacity (0-100) of Methodology assessment and Rating of statistical capacity (0-100) of Overall level?
Offer a terse response. -32.22. In the year 2009, what is the difference between the Rating of statistical capacity (0-100) in Methodology assessment and Rating of statistical capacity (0-100) in Periodicity assessment?
Offer a very short reply. -56.67. In the year 2009, what is the difference between the Rating of statistical capacity (0-100) in Overall level and Rating of statistical capacity (0-100) in Periodicity assessment?
Offer a terse response. -24.44. In the year 2009, what is the difference between the Rating of statistical capacity (0-100) in Overall level and Rating of statistical capacity (0-100) in Source data assessment?
Ensure brevity in your answer.  -7.78. In the year 2009, what is the difference between the Rating of statistical capacity (0-100) in Periodicity assessment and Rating of statistical capacity (0-100) in Source data assessment?
Make the answer very short. 16.67. In the year 2010, what is the difference between the Rating of statistical capacity (0-100) of Methodology assessment and Rating of statistical capacity (0-100) of Overall level?
Your answer should be compact. -37.78. In the year 2010, what is the difference between the Rating of statistical capacity (0-100) in Methodology assessment and Rating of statistical capacity (0-100) in Periodicity assessment?
Your answer should be compact. -63.33. In the year 2010, what is the difference between the Rating of statistical capacity (0-100) of Methodology assessment and Rating of statistical capacity (0-100) of Source data assessment?
Provide a succinct answer. -50. In the year 2010, what is the difference between the Rating of statistical capacity (0-100) of Overall level and Rating of statistical capacity (0-100) of Periodicity assessment?
Your answer should be compact. -25.56. In the year 2010, what is the difference between the Rating of statistical capacity (0-100) of Overall level and Rating of statistical capacity (0-100) of Source data assessment?
Your answer should be compact. -12.22. In the year 2010, what is the difference between the Rating of statistical capacity (0-100) in Periodicity assessment and Rating of statistical capacity (0-100) in Source data assessment?
Offer a terse response. 13.33. In the year 2011, what is the difference between the Rating of statistical capacity (0-100) in Methodology assessment and Rating of statistical capacity (0-100) in Overall level?
Your response must be concise. -31.11. In the year 2011, what is the difference between the Rating of statistical capacity (0-100) in Methodology assessment and Rating of statistical capacity (0-100) in Periodicity assessment?
Offer a very short reply. -53.33. In the year 2011, what is the difference between the Rating of statistical capacity (0-100) in Overall level and Rating of statistical capacity (0-100) in Periodicity assessment?
Offer a very short reply. -22.22. In the year 2011, what is the difference between the Rating of statistical capacity (0-100) of Overall level and Rating of statistical capacity (0-100) of Source data assessment?
Ensure brevity in your answer.  -8.89. In the year 2011, what is the difference between the Rating of statistical capacity (0-100) of Periodicity assessment and Rating of statistical capacity (0-100) of Source data assessment?
Provide a succinct answer. 13.33. In the year 2012, what is the difference between the Rating of statistical capacity (0-100) of Methodology assessment and Rating of statistical capacity (0-100) of Periodicity assessment?
Make the answer very short. -50. In the year 2012, what is the difference between the Rating of statistical capacity (0-100) in Methodology assessment and Rating of statistical capacity (0-100) in Source data assessment?
Keep it short and to the point. -40. In the year 2013, what is the difference between the Rating of statistical capacity (0-100) of Methodology assessment and Rating of statistical capacity (0-100) of Overall level?
Give a very brief answer. -22.22. In the year 2013, what is the difference between the Rating of statistical capacity (0-100) of Methodology assessment and Rating of statistical capacity (0-100) of Periodicity assessment?
Provide a short and direct response. -36.67. In the year 2013, what is the difference between the Rating of statistical capacity (0-100) in Methodology assessment and Rating of statistical capacity (0-100) in Source data assessment?
Ensure brevity in your answer.  -30. In the year 2013, what is the difference between the Rating of statistical capacity (0-100) of Overall level and Rating of statistical capacity (0-100) of Periodicity assessment?
Give a very brief answer. -14.44. In the year 2013, what is the difference between the Rating of statistical capacity (0-100) in Overall level and Rating of statistical capacity (0-100) in Source data assessment?
Offer a terse response. -7.78. In the year 2014, what is the difference between the Rating of statistical capacity (0-100) in Methodology assessment and Rating of statistical capacity (0-100) in Overall level?
Make the answer very short. -27.78. In the year 2014, what is the difference between the Rating of statistical capacity (0-100) of Methodology assessment and Rating of statistical capacity (0-100) of Periodicity assessment?
Your answer should be very brief. -43.33. In the year 2014, what is the difference between the Rating of statistical capacity (0-100) in Methodology assessment and Rating of statistical capacity (0-100) in Source data assessment?
Offer a very short reply. -40. In the year 2014, what is the difference between the Rating of statistical capacity (0-100) of Overall level and Rating of statistical capacity (0-100) of Periodicity assessment?
Keep it short and to the point. -15.56. In the year 2014, what is the difference between the Rating of statistical capacity (0-100) in Overall level and Rating of statistical capacity (0-100) in Source data assessment?
Provide a short and direct response. -12.22. What is the ratio of the Rating of statistical capacity (0-100) of Overall level in 2006 to that in 2007?
Offer a very short reply. 1. What is the ratio of the Rating of statistical capacity (0-100) in Methodology assessment in 2006 to that in 2008?
Offer a very short reply. 1.67. What is the ratio of the Rating of statistical capacity (0-100) of Overall level in 2006 to that in 2008?
Your answer should be compact. 1.13. What is the ratio of the Rating of statistical capacity (0-100) in Periodicity assessment in 2006 to that in 2008?
Ensure brevity in your answer.  1.04. What is the ratio of the Rating of statistical capacity (0-100) of Overall level in 2006 to that in 2009?
Your answer should be very brief. 1.11. What is the ratio of the Rating of statistical capacity (0-100) of Source data assessment in 2006 to that in 2009?
Your answer should be very brief. 1. What is the ratio of the Rating of statistical capacity (0-100) in Methodology assessment in 2006 to that in 2010?
Your answer should be compact. 1.67. What is the ratio of the Rating of statistical capacity (0-100) of Overall level in 2006 to that in 2010?
Give a very brief answer. 1.02. What is the ratio of the Rating of statistical capacity (0-100) in Periodicity assessment in 2006 to that in 2010?
Give a very brief answer. 0.93. What is the ratio of the Rating of statistical capacity (0-100) of Methodology assessment in 2006 to that in 2011?
Your response must be concise. 1.25. What is the ratio of the Rating of statistical capacity (0-100) of Overall level in 2006 to that in 2011?
Ensure brevity in your answer.  0.97. What is the ratio of the Rating of statistical capacity (0-100) of Source data assessment in 2006 to that in 2011?
Your answer should be compact. 0.88. What is the ratio of the Rating of statistical capacity (0-100) in Methodology assessment in 2006 to that in 2012?
Make the answer very short. 1.25. What is the ratio of the Rating of statistical capacity (0-100) in Overall level in 2006 to that in 2012?
Your answer should be very brief. 0.98. What is the ratio of the Rating of statistical capacity (0-100) in Periodicity assessment in 2006 to that in 2012?
Ensure brevity in your answer.  0.96. What is the ratio of the Rating of statistical capacity (0-100) in Methodology assessment in 2006 to that in 2013?
Keep it short and to the point. 1. What is the ratio of the Rating of statistical capacity (0-100) in Overall level in 2006 to that in 2013?
Your response must be concise. 0.95. What is the ratio of the Rating of statistical capacity (0-100) of Methodology assessment in 2006 to that in 2014?
Offer a terse response. 1.25. What is the ratio of the Rating of statistical capacity (0-100) in Overall level in 2006 to that in 2014?
Give a very brief answer. 1.02. What is the ratio of the Rating of statistical capacity (0-100) of Methodology assessment in 2007 to that in 2008?
Your answer should be compact. 1.67. What is the ratio of the Rating of statistical capacity (0-100) of Overall level in 2007 to that in 2008?
Provide a short and direct response. 1.13. What is the ratio of the Rating of statistical capacity (0-100) in Source data assessment in 2007 to that in 2008?
Offer a very short reply. 1. What is the ratio of the Rating of statistical capacity (0-100) of Methodology assessment in 2007 to that in 2009?
Offer a terse response. 1.67. What is the ratio of the Rating of statistical capacity (0-100) in Overall level in 2007 to that in 2009?
Your response must be concise. 1.11. What is the ratio of the Rating of statistical capacity (0-100) in Periodicity assessment in 2007 to that in 2009?
Your answer should be compact. 1. What is the ratio of the Rating of statistical capacity (0-100) in Overall level in 2007 to that in 2010?
Give a very brief answer. 1.02. What is the ratio of the Rating of statistical capacity (0-100) of Overall level in 2007 to that in 2011?
Offer a terse response. 0.97. What is the ratio of the Rating of statistical capacity (0-100) in Methodology assessment in 2007 to that in 2012?
Your answer should be compact. 1.25. What is the ratio of the Rating of statistical capacity (0-100) in Overall level in 2007 to that in 2012?
Provide a short and direct response. 0.98. What is the ratio of the Rating of statistical capacity (0-100) of Methodology assessment in 2007 to that in 2013?
Give a very brief answer. 1. What is the ratio of the Rating of statistical capacity (0-100) of Overall level in 2007 to that in 2013?
Ensure brevity in your answer.  0.95. What is the ratio of the Rating of statistical capacity (0-100) of Periodicity assessment in 2007 to that in 2013?
Make the answer very short. 1. What is the ratio of the Rating of statistical capacity (0-100) of Methodology assessment in 2007 to that in 2014?
Offer a very short reply. 1.25. What is the ratio of the Rating of statistical capacity (0-100) in Overall level in 2007 to that in 2014?
Offer a very short reply. 1.02. What is the ratio of the Rating of statistical capacity (0-100) in Methodology assessment in 2008 to that in 2009?
Offer a very short reply. 1. What is the ratio of the Rating of statistical capacity (0-100) in Overall level in 2008 to that in 2009?
Ensure brevity in your answer.  0.98. What is the ratio of the Rating of statistical capacity (0-100) of Periodicity assessment in 2008 to that in 2009?
Your answer should be very brief. 0.96. What is the ratio of the Rating of statistical capacity (0-100) in Source data assessment in 2008 to that in 2009?
Ensure brevity in your answer.  1. What is the ratio of the Rating of statistical capacity (0-100) of Overall level in 2008 to that in 2010?
Your answer should be very brief. 0.9. What is the ratio of the Rating of statistical capacity (0-100) of Periodicity assessment in 2008 to that in 2010?
Ensure brevity in your answer.  0.89. What is the ratio of the Rating of statistical capacity (0-100) of Overall level in 2008 to that in 2011?
Ensure brevity in your answer.  0.86. What is the ratio of the Rating of statistical capacity (0-100) in Periodicity assessment in 2008 to that in 2011?
Your answer should be very brief. 0.89. What is the ratio of the Rating of statistical capacity (0-100) of Methodology assessment in 2008 to that in 2012?
Keep it short and to the point. 0.75. What is the ratio of the Rating of statistical capacity (0-100) in Overall level in 2008 to that in 2012?
Provide a short and direct response. 0.87. What is the ratio of the Rating of statistical capacity (0-100) in Periodicity assessment in 2008 to that in 2012?
Give a very brief answer. 0.93. What is the ratio of the Rating of statistical capacity (0-100) in Source data assessment in 2008 to that in 2012?
Make the answer very short. 0.88. What is the ratio of the Rating of statistical capacity (0-100) of Methodology assessment in 2008 to that in 2013?
Your answer should be very brief. 0.6. What is the ratio of the Rating of statistical capacity (0-100) of Overall level in 2008 to that in 2013?
Ensure brevity in your answer.  0.85. What is the ratio of the Rating of statistical capacity (0-100) of Periodicity assessment in 2008 to that in 2013?
Provide a succinct answer. 0.96. What is the ratio of the Rating of statistical capacity (0-100) of Overall level in 2008 to that in 2014?
Offer a terse response. 0.9. What is the ratio of the Rating of statistical capacity (0-100) of Source data assessment in 2008 to that in 2014?
Your answer should be compact. 0.88. What is the ratio of the Rating of statistical capacity (0-100) of Methodology assessment in 2009 to that in 2010?
Your answer should be compact. 1. What is the ratio of the Rating of statistical capacity (0-100) in Overall level in 2009 to that in 2010?
Ensure brevity in your answer.  0.92. What is the ratio of the Rating of statistical capacity (0-100) in Periodicity assessment in 2009 to that in 2010?
Provide a succinct answer. 0.93. What is the ratio of the Rating of statistical capacity (0-100) in Source data assessment in 2009 to that in 2010?
Offer a terse response. 0.88. What is the ratio of the Rating of statistical capacity (0-100) of Overall level in 2009 to that in 2011?
Offer a very short reply. 0.88. What is the ratio of the Rating of statistical capacity (0-100) of Periodicity assessment in 2009 to that in 2011?
Ensure brevity in your answer.  0.93. What is the ratio of the Rating of statistical capacity (0-100) in Source data assessment in 2009 to that in 2011?
Make the answer very short. 0.88. What is the ratio of the Rating of statistical capacity (0-100) of Overall level in 2009 to that in 2012?
Make the answer very short. 0.89. What is the ratio of the Rating of statistical capacity (0-100) of Methodology assessment in 2009 to that in 2013?
Your response must be concise. 0.6. What is the ratio of the Rating of statistical capacity (0-100) in Overall level in 2009 to that in 2013?
Provide a short and direct response. 0.86. What is the ratio of the Rating of statistical capacity (0-100) in Overall level in 2009 to that in 2014?
Keep it short and to the point. 0.92. What is the ratio of the Rating of statistical capacity (0-100) in Periodicity assessment in 2009 to that in 2014?
Your response must be concise. 1.04. What is the ratio of the Rating of statistical capacity (0-100) of Methodology assessment in 2010 to that in 2011?
Your response must be concise. 0.75. What is the ratio of the Rating of statistical capacity (0-100) of Overall level in 2010 to that in 2011?
Your answer should be compact. 0.95. What is the ratio of the Rating of statistical capacity (0-100) of Periodicity assessment in 2010 to that in 2011?
Provide a short and direct response. 1. What is the ratio of the Rating of statistical capacity (0-100) of Source data assessment in 2010 to that in 2011?
Offer a terse response. 1. What is the ratio of the Rating of statistical capacity (0-100) in Overall level in 2010 to that in 2012?
Offer a terse response. 0.97. What is the ratio of the Rating of statistical capacity (0-100) in Periodicity assessment in 2010 to that in 2012?
Make the answer very short. 1.04. What is the ratio of the Rating of statistical capacity (0-100) of Source data assessment in 2010 to that in 2012?
Offer a very short reply. 1. What is the ratio of the Rating of statistical capacity (0-100) of Overall level in 2010 to that in 2013?
Offer a terse response. 0.94. What is the ratio of the Rating of statistical capacity (0-100) in Periodicity assessment in 2010 to that in 2013?
Offer a terse response. 1.08. What is the ratio of the Rating of statistical capacity (0-100) in Source data assessment in 2010 to that in 2013?
Provide a succinct answer. 1. What is the ratio of the Rating of statistical capacity (0-100) of Methodology assessment in 2010 to that in 2014?
Your answer should be compact. 0.75. What is the ratio of the Rating of statistical capacity (0-100) of Periodicity assessment in 2010 to that in 2014?
Keep it short and to the point. 1.12. What is the ratio of the Rating of statistical capacity (0-100) of Methodology assessment in 2011 to that in 2012?
Ensure brevity in your answer.  1. What is the ratio of the Rating of statistical capacity (0-100) of Overall level in 2011 to that in 2012?
Provide a succinct answer. 1.02. What is the ratio of the Rating of statistical capacity (0-100) in Overall level in 2011 to that in 2013?
Ensure brevity in your answer.  0.98. What is the ratio of the Rating of statistical capacity (0-100) of Periodicity assessment in 2011 to that in 2013?
Your answer should be compact. 1.08. What is the ratio of the Rating of statistical capacity (0-100) of Source data assessment in 2011 to that in 2013?
Your answer should be very brief. 1. What is the ratio of the Rating of statistical capacity (0-100) in Overall level in 2011 to that in 2014?
Provide a short and direct response. 1.05. What is the ratio of the Rating of statistical capacity (0-100) of Periodicity assessment in 2011 to that in 2014?
Your answer should be compact. 1.12. What is the ratio of the Rating of statistical capacity (0-100) of Methodology assessment in 2012 to that in 2013?
Your response must be concise. 0.8. What is the ratio of the Rating of statistical capacity (0-100) of Overall level in 2012 to that in 2013?
Your response must be concise. 0.97. What is the ratio of the Rating of statistical capacity (0-100) in Periodicity assessment in 2012 to that in 2013?
Offer a terse response. 1.04. What is the ratio of the Rating of statistical capacity (0-100) of Source data assessment in 2012 to that in 2013?
Provide a succinct answer. 1. What is the ratio of the Rating of statistical capacity (0-100) in Overall level in 2012 to that in 2014?
Your answer should be compact. 1.03. What is the ratio of the Rating of statistical capacity (0-100) of Overall level in 2013 to that in 2014?
Give a very brief answer. 1.07. What is the difference between the highest and the second highest Rating of statistical capacity (0-100) of Overall level?
Provide a short and direct response. 1.11. What is the difference between the highest and the second highest Rating of statistical capacity (0-100) of Periodicity assessment?
Provide a succinct answer. 0. What is the difference between the highest and the second highest Rating of statistical capacity (0-100) in Source data assessment?
Your answer should be compact. 0. What is the difference between the highest and the lowest Rating of statistical capacity (0-100) of Overall level?
Your answer should be very brief. 11.11. 